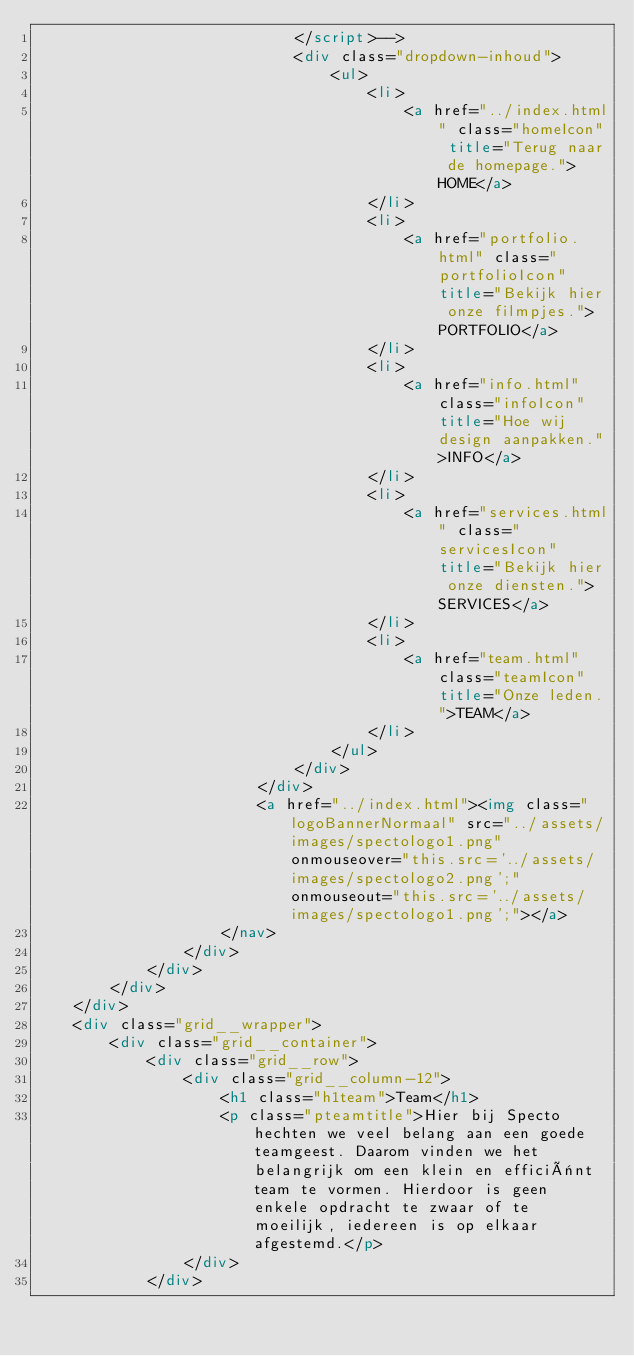Convert code to text. <code><loc_0><loc_0><loc_500><loc_500><_HTML_>							</script>-->
							<div class="dropdown-inhoud">
								<ul>
									<li>
										<a href="../index.html" class="homeIcon" title="Terug naar de homepage.">HOME</a>
									</li>
									<li>
										<a href="portfolio.html" class="portfolioIcon" title="Bekijk hier onze filmpjes.">PORTFOLIO</a>
									</li>
									<li>
										<a href="info.html" class="infoIcon" title="Hoe wij design aanpakken.">INFO</a>
									</li>
									<li>
										<a href="services.html" class="servicesIcon" title="Bekijk hier onze diensten.">SERVICES</a>
									</li>
									<li>
										<a href="team.html" class="teamIcon" title="Onze leden.">TEAM</a>
									</li>
								</ul>
							</div>
						</div>
						<a href="../index.html"><img class="logoBannerNormaal" src="../assets/images/spectologo1.png" onmouseover="this.src='../assets/images/spectologo2.png';" onmouseout="this.src='../assets/images/spectologo1.png';"></a>
					</nav>
				</div>	
			</div>
		</div>
	</div>
	<div class="grid__wrapper">
		<div class="grid__container">
			<div class="grid__row">
				<div class="grid__column-12">
					<h1 class="h1team">Team</h1>
					<p class="pteamtitle">Hier bij Specto hechten we veel belang aan een goede teamgeest. Daarom vinden we het belangrijk om een klein en efficiënt team te vormen. Hierdoor is geen enkele opdracht te zwaar of te moeilijk, iedereen is op elkaar afgestemd.</p>
				</div>
			</div></code> 